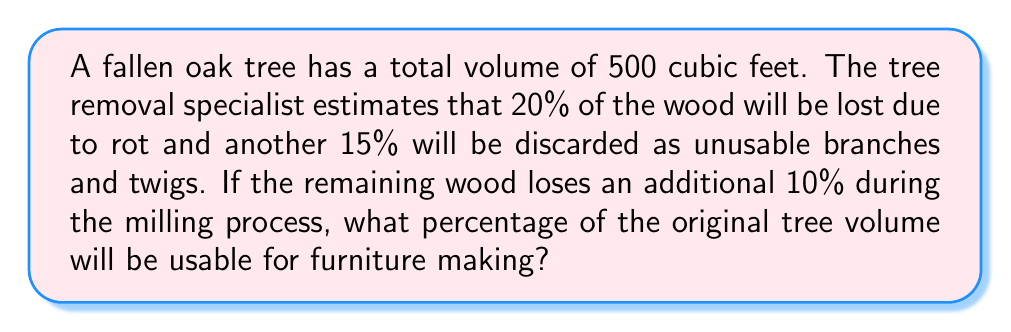What is the answer to this math problem? Let's approach this step-by-step:

1) First, calculate the volume of wood remaining after initial losses:
   - Loss due to rot: $20\% = 0.20 \times 500 = 100$ cubic feet
   - Loss due to unusable parts: $15\% = 0.15 \times 500 = 75$ cubic feet
   - Total initial loss: $100 + 75 = 175$ cubic feet
   - Remaining wood: $500 - 175 = 325$ cubic feet

2) Calculate the percentage of wood remaining after initial losses:
   $$\frac{325}{500} \times 100\% = 65\%$$

3) Now, account for the additional 10% loss during milling:
   - Usable wood = $325 \times (1 - 0.10) = 325 \times 0.90 = 292.5$ cubic feet

4) Calculate the final percentage of usable wood:
   $$\frac{292.5}{500} \times 100\% = 58.5\%$$

Therefore, 58.5% of the original tree volume will be usable for furniture making.
Answer: 58.5% 